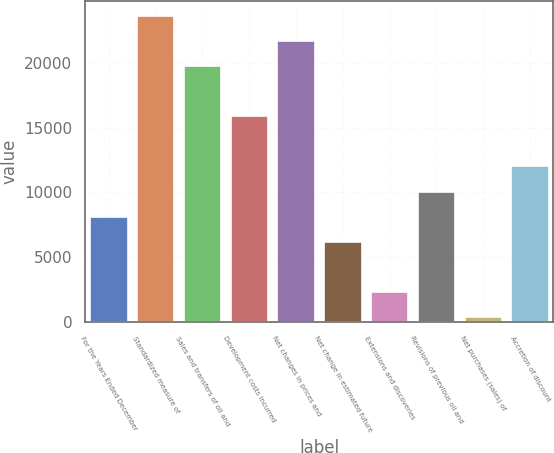<chart> <loc_0><loc_0><loc_500><loc_500><bar_chart><fcel>For the Years Ended December<fcel>Standardized measure of<fcel>Sales and transfers of oil and<fcel>Development costs incurred<fcel>Net changes in prices and<fcel>Net change in estimated future<fcel>Extensions and discoveries<fcel>Revisions of previous oil and<fcel>Net purchases (sales) of<fcel>Accretion of discount<nl><fcel>8134<fcel>23606<fcel>19738<fcel>15870<fcel>21672<fcel>6200<fcel>2332<fcel>10068<fcel>398<fcel>12002<nl></chart> 